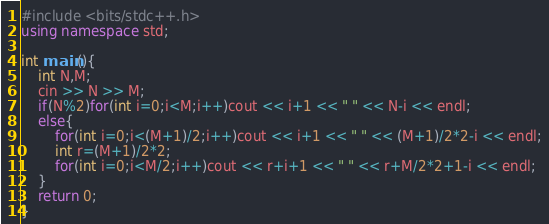Convert code to text. <code><loc_0><loc_0><loc_500><loc_500><_C++_>#include <bits/stdc++.h>
using namespace std;

int main(){
	int N,M;
	cin >> N >> M;
	if(N%2)for(int i=0;i<M;i++)cout << i+1 << " " << N-i << endl;
	else{
		for(int i=0;i<(M+1)/2;i++)cout << i+1 << " " << (M+1)/2*2-i << endl;
		int r=(M+1)/2*2;
		for(int i=0;i<M/2;i++)cout << r+i+1 << " " << r+M/2*2+1-i << endl;
	}
	return 0;
}</code> 